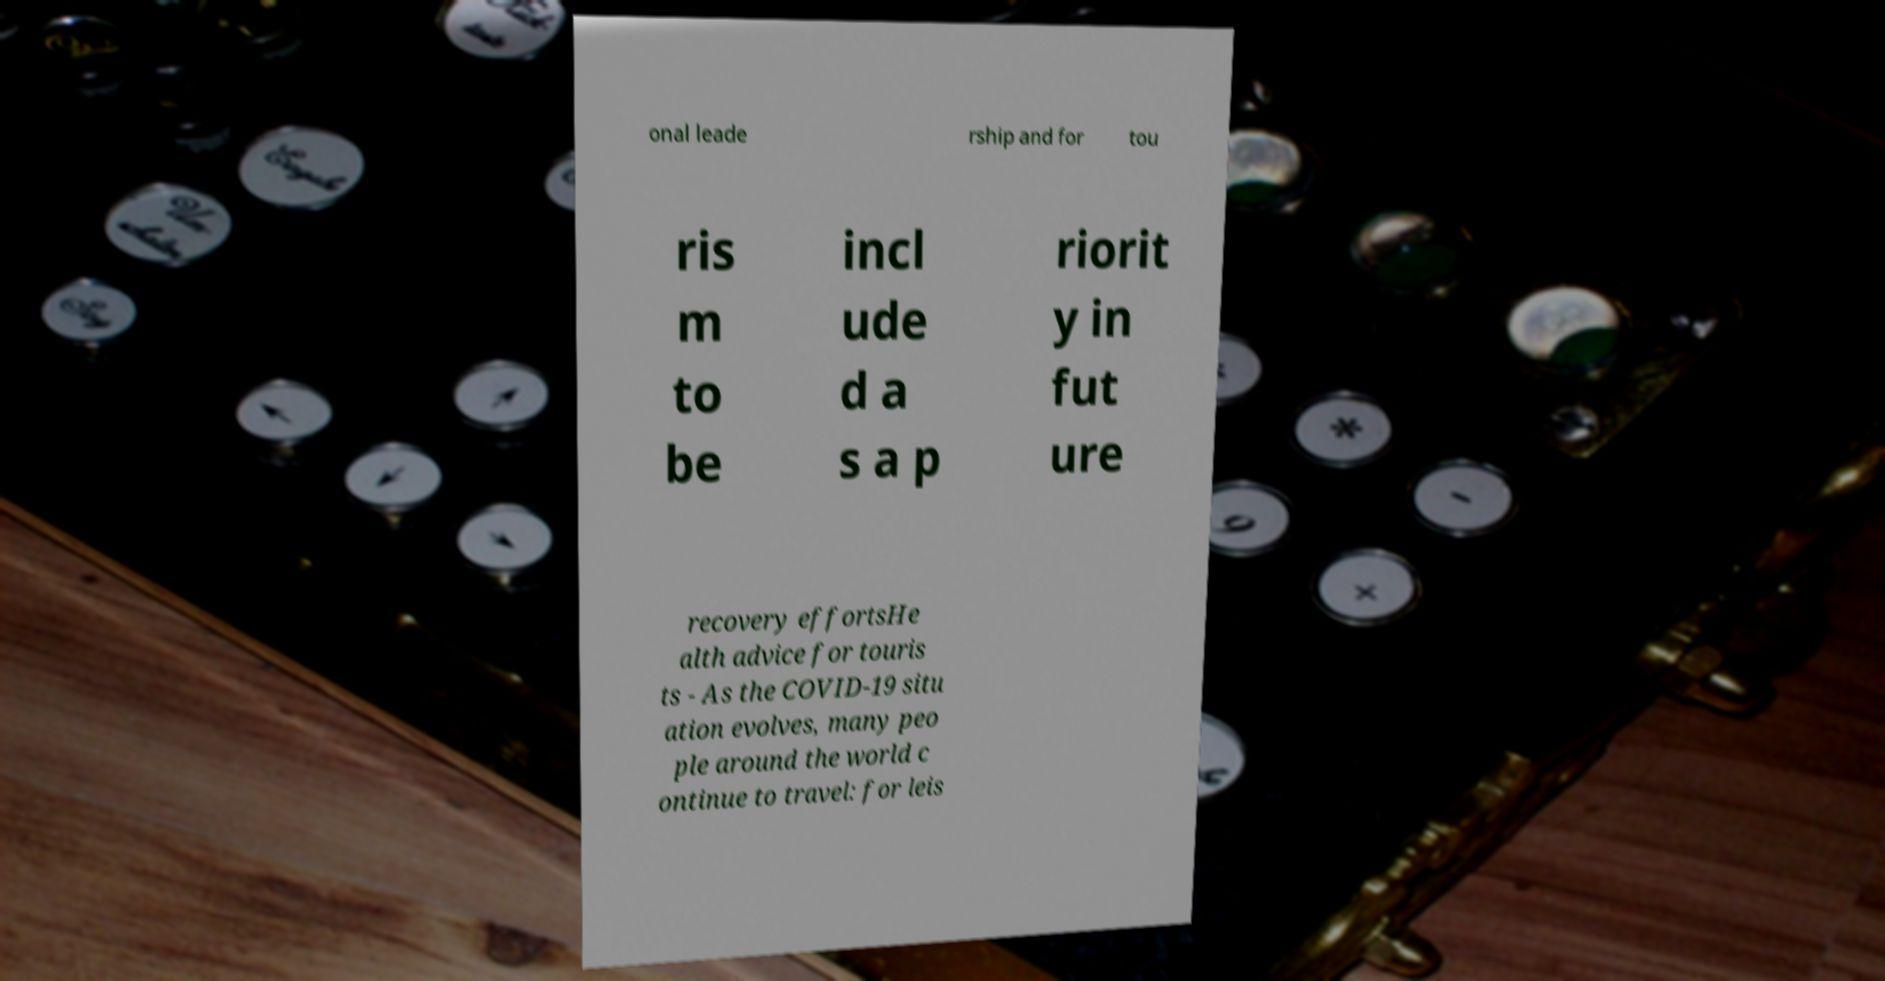Please read and relay the text visible in this image. What does it say? onal leade rship and for tou ris m to be incl ude d a s a p riorit y in fut ure recovery effortsHe alth advice for touris ts - As the COVID-19 situ ation evolves, many peo ple around the world c ontinue to travel: for leis 